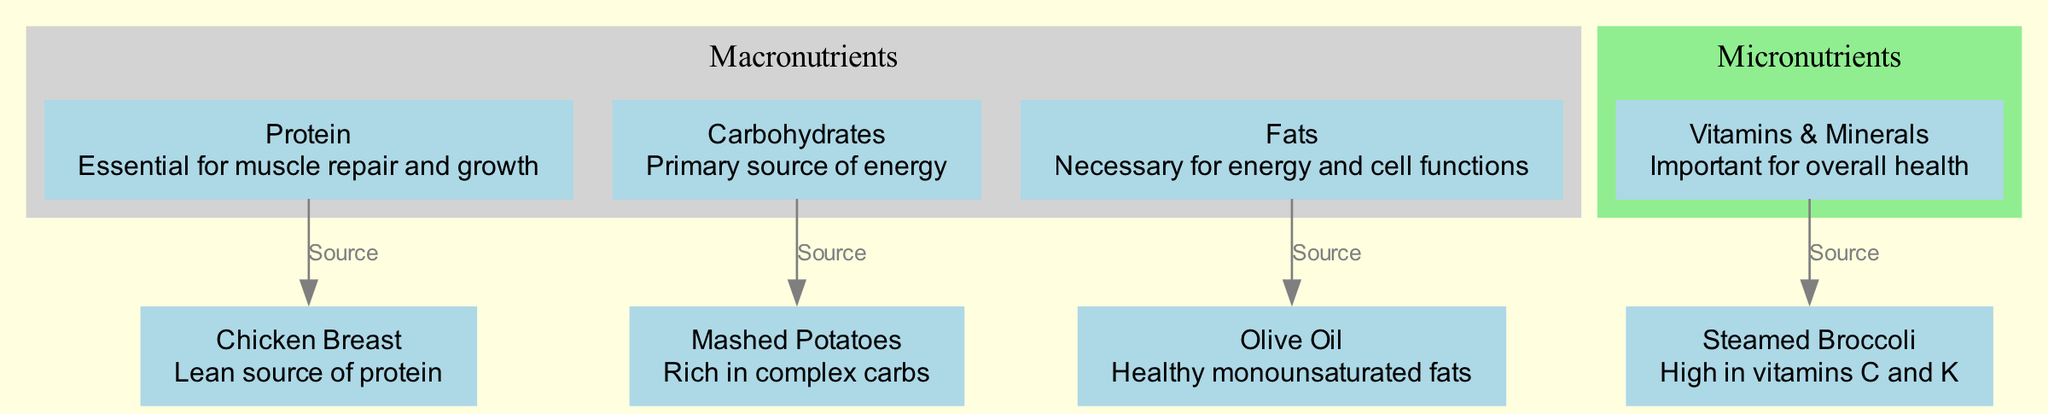What does chicken breast provide? The diagram shows an arrow labeled "Source" connecting "Protein" to "Chicken Breast," revealing that chicken breast is a source of protein.
Answer: Protein How many macronutrient nodes are there? The diagram features three macronutrient nodes: "Protein," "Carbohydrates," and "Fats," which can be counted directly.
Answer: 3 Which food is high in vitamins C and K? The node for "Steamed Broccoli" includes the description indicating that it is high in vitamins C and K, which directly answers the question.
Answer: Steamed Broccoli What type of fat is olive oil classified as? The label for "Olive Oil" in the diagram indicates that it consists of "Healthy monounsaturated fats," which answers the question about its classification.
Answer: Monounsaturated What nutrient is mashed potatoes primarily a source of? The edge labeled "Source" connects "Carbohydrates" to "Mashed Potatoes," indicating that mashed potatoes are primarily a source of carbohydrates.
Answer: Carbohydrates Which category does steamed broccoli fall under? In the diagram, "Steamed Broccoli" is linked to the "Vitamins & Minerals" node, suggesting it is part of the micronutrients category.
Answer: Micronutrients What is the relationship between fats and olive oil? The diagram shows a directed edge labeled "Source" from "Fats" to "Olive Oil," indicating that olive oil is a source of fats.
Answer: Source What are the two main categories of nutrients depicted in the diagram? The diagram features distinct clusters labeled "Macronutrients" and "Micronutrients," delineating the two main nutrient categories presented.
Answer: Macronutrients, Micronutrients How many edges connect food items to their nutrient categories? The connections from "Chicken Breast," "Mashed Potatoes," "Steamed Broccoli," and "Olive Oil" to their respective nutrient categories indicate there are four edges in total.
Answer: 4 